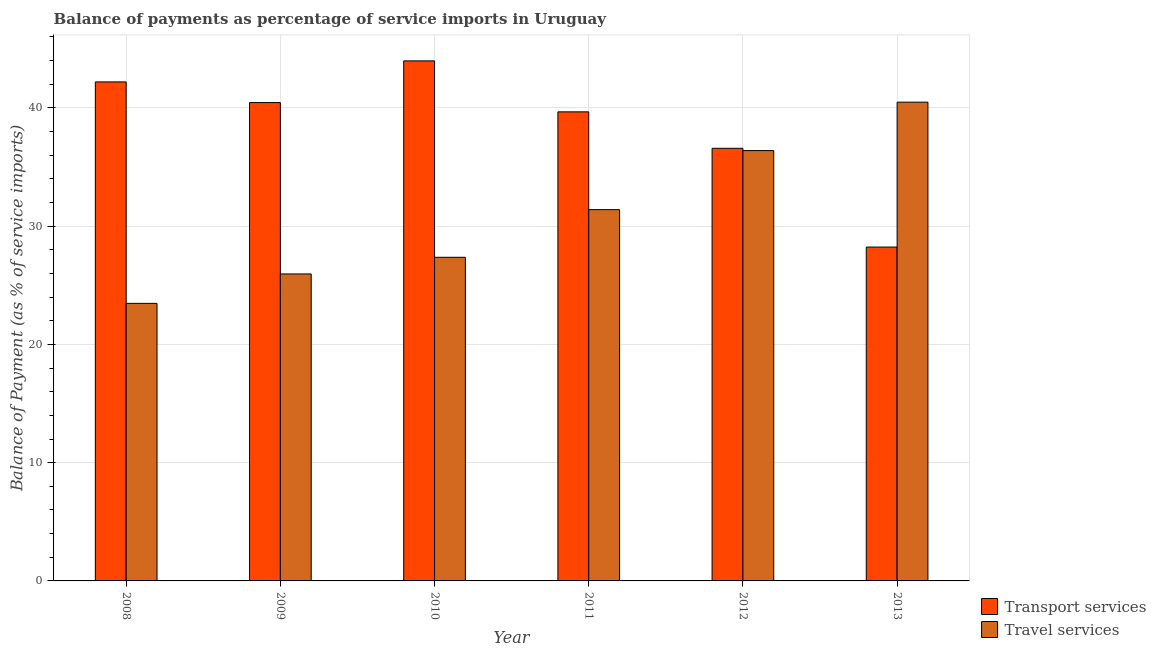How many bars are there on the 6th tick from the left?
Your answer should be compact. 2. What is the label of the 1st group of bars from the left?
Ensure brevity in your answer.  2008. In how many cases, is the number of bars for a given year not equal to the number of legend labels?
Offer a very short reply. 0. What is the balance of payments of travel services in 2008?
Offer a terse response. 23.47. Across all years, what is the maximum balance of payments of travel services?
Ensure brevity in your answer.  40.48. Across all years, what is the minimum balance of payments of transport services?
Provide a succinct answer. 28.23. In which year was the balance of payments of transport services maximum?
Offer a terse response. 2010. In which year was the balance of payments of travel services minimum?
Provide a succinct answer. 2008. What is the total balance of payments of travel services in the graph?
Your answer should be compact. 185.06. What is the difference between the balance of payments of travel services in 2008 and that in 2013?
Make the answer very short. -17.01. What is the difference between the balance of payments of travel services in 2010 and the balance of payments of transport services in 2009?
Offer a terse response. 1.41. What is the average balance of payments of travel services per year?
Provide a short and direct response. 30.84. In the year 2010, what is the difference between the balance of payments of travel services and balance of payments of transport services?
Provide a short and direct response. 0. In how many years, is the balance of payments of transport services greater than 16 %?
Your answer should be very brief. 6. What is the ratio of the balance of payments of transport services in 2008 to that in 2009?
Give a very brief answer. 1.04. What is the difference between the highest and the second highest balance of payments of transport services?
Ensure brevity in your answer.  1.78. What is the difference between the highest and the lowest balance of payments of travel services?
Your response must be concise. 17.01. Is the sum of the balance of payments of travel services in 2009 and 2012 greater than the maximum balance of payments of transport services across all years?
Offer a terse response. Yes. What does the 2nd bar from the left in 2011 represents?
Your answer should be very brief. Travel services. What does the 1st bar from the right in 2008 represents?
Provide a succinct answer. Travel services. Are all the bars in the graph horizontal?
Offer a terse response. No. How many years are there in the graph?
Your answer should be very brief. 6. What is the difference between two consecutive major ticks on the Y-axis?
Your answer should be very brief. 10. Does the graph contain grids?
Your response must be concise. Yes. Where does the legend appear in the graph?
Offer a very short reply. Bottom right. How many legend labels are there?
Make the answer very short. 2. How are the legend labels stacked?
Your answer should be very brief. Vertical. What is the title of the graph?
Your answer should be very brief. Balance of payments as percentage of service imports in Uruguay. Does "Public credit registry" appear as one of the legend labels in the graph?
Your answer should be compact. No. What is the label or title of the Y-axis?
Make the answer very short. Balance of Payment (as % of service imports). What is the Balance of Payment (as % of service imports) in Transport services in 2008?
Ensure brevity in your answer.  42.2. What is the Balance of Payment (as % of service imports) in Travel services in 2008?
Provide a succinct answer. 23.47. What is the Balance of Payment (as % of service imports) in Transport services in 2009?
Provide a succinct answer. 40.45. What is the Balance of Payment (as % of service imports) in Travel services in 2009?
Make the answer very short. 25.96. What is the Balance of Payment (as % of service imports) of Transport services in 2010?
Offer a terse response. 43.98. What is the Balance of Payment (as % of service imports) of Travel services in 2010?
Offer a terse response. 27.37. What is the Balance of Payment (as % of service imports) of Transport services in 2011?
Offer a very short reply. 39.66. What is the Balance of Payment (as % of service imports) of Travel services in 2011?
Give a very brief answer. 31.39. What is the Balance of Payment (as % of service imports) in Transport services in 2012?
Ensure brevity in your answer.  36.58. What is the Balance of Payment (as % of service imports) of Travel services in 2012?
Your answer should be very brief. 36.39. What is the Balance of Payment (as % of service imports) of Transport services in 2013?
Your answer should be very brief. 28.23. What is the Balance of Payment (as % of service imports) in Travel services in 2013?
Your answer should be compact. 40.48. Across all years, what is the maximum Balance of Payment (as % of service imports) of Transport services?
Offer a terse response. 43.98. Across all years, what is the maximum Balance of Payment (as % of service imports) in Travel services?
Your response must be concise. 40.48. Across all years, what is the minimum Balance of Payment (as % of service imports) in Transport services?
Your answer should be very brief. 28.23. Across all years, what is the minimum Balance of Payment (as % of service imports) of Travel services?
Provide a short and direct response. 23.47. What is the total Balance of Payment (as % of service imports) in Transport services in the graph?
Your response must be concise. 231.1. What is the total Balance of Payment (as % of service imports) of Travel services in the graph?
Provide a short and direct response. 185.06. What is the difference between the Balance of Payment (as % of service imports) in Transport services in 2008 and that in 2009?
Your answer should be very brief. 1.75. What is the difference between the Balance of Payment (as % of service imports) of Travel services in 2008 and that in 2009?
Make the answer very short. -2.49. What is the difference between the Balance of Payment (as % of service imports) of Transport services in 2008 and that in 2010?
Keep it short and to the point. -1.78. What is the difference between the Balance of Payment (as % of service imports) of Travel services in 2008 and that in 2010?
Your response must be concise. -3.9. What is the difference between the Balance of Payment (as % of service imports) in Transport services in 2008 and that in 2011?
Ensure brevity in your answer.  2.53. What is the difference between the Balance of Payment (as % of service imports) in Travel services in 2008 and that in 2011?
Offer a terse response. -7.92. What is the difference between the Balance of Payment (as % of service imports) in Transport services in 2008 and that in 2012?
Make the answer very short. 5.61. What is the difference between the Balance of Payment (as % of service imports) of Travel services in 2008 and that in 2012?
Your response must be concise. -12.92. What is the difference between the Balance of Payment (as % of service imports) in Transport services in 2008 and that in 2013?
Your response must be concise. 13.96. What is the difference between the Balance of Payment (as % of service imports) in Travel services in 2008 and that in 2013?
Your answer should be very brief. -17.01. What is the difference between the Balance of Payment (as % of service imports) of Transport services in 2009 and that in 2010?
Give a very brief answer. -3.53. What is the difference between the Balance of Payment (as % of service imports) of Travel services in 2009 and that in 2010?
Give a very brief answer. -1.41. What is the difference between the Balance of Payment (as % of service imports) of Transport services in 2009 and that in 2011?
Give a very brief answer. 0.78. What is the difference between the Balance of Payment (as % of service imports) in Travel services in 2009 and that in 2011?
Your answer should be very brief. -5.44. What is the difference between the Balance of Payment (as % of service imports) of Transport services in 2009 and that in 2012?
Offer a very short reply. 3.87. What is the difference between the Balance of Payment (as % of service imports) of Travel services in 2009 and that in 2012?
Offer a terse response. -10.43. What is the difference between the Balance of Payment (as % of service imports) of Transport services in 2009 and that in 2013?
Make the answer very short. 12.22. What is the difference between the Balance of Payment (as % of service imports) of Travel services in 2009 and that in 2013?
Make the answer very short. -14.52. What is the difference between the Balance of Payment (as % of service imports) of Transport services in 2010 and that in 2011?
Offer a terse response. 4.31. What is the difference between the Balance of Payment (as % of service imports) of Travel services in 2010 and that in 2011?
Offer a very short reply. -4.03. What is the difference between the Balance of Payment (as % of service imports) of Transport services in 2010 and that in 2012?
Offer a very short reply. 7.39. What is the difference between the Balance of Payment (as % of service imports) in Travel services in 2010 and that in 2012?
Provide a short and direct response. -9.02. What is the difference between the Balance of Payment (as % of service imports) in Transport services in 2010 and that in 2013?
Your answer should be compact. 15.74. What is the difference between the Balance of Payment (as % of service imports) of Travel services in 2010 and that in 2013?
Provide a short and direct response. -13.12. What is the difference between the Balance of Payment (as % of service imports) in Transport services in 2011 and that in 2012?
Offer a terse response. 3.08. What is the difference between the Balance of Payment (as % of service imports) of Travel services in 2011 and that in 2012?
Keep it short and to the point. -5. What is the difference between the Balance of Payment (as % of service imports) of Transport services in 2011 and that in 2013?
Keep it short and to the point. 11.43. What is the difference between the Balance of Payment (as % of service imports) of Travel services in 2011 and that in 2013?
Ensure brevity in your answer.  -9.09. What is the difference between the Balance of Payment (as % of service imports) of Transport services in 2012 and that in 2013?
Give a very brief answer. 8.35. What is the difference between the Balance of Payment (as % of service imports) in Travel services in 2012 and that in 2013?
Your response must be concise. -4.09. What is the difference between the Balance of Payment (as % of service imports) of Transport services in 2008 and the Balance of Payment (as % of service imports) of Travel services in 2009?
Keep it short and to the point. 16.24. What is the difference between the Balance of Payment (as % of service imports) in Transport services in 2008 and the Balance of Payment (as % of service imports) in Travel services in 2010?
Provide a short and direct response. 14.83. What is the difference between the Balance of Payment (as % of service imports) of Transport services in 2008 and the Balance of Payment (as % of service imports) of Travel services in 2011?
Provide a short and direct response. 10.8. What is the difference between the Balance of Payment (as % of service imports) in Transport services in 2008 and the Balance of Payment (as % of service imports) in Travel services in 2012?
Offer a very short reply. 5.81. What is the difference between the Balance of Payment (as % of service imports) of Transport services in 2008 and the Balance of Payment (as % of service imports) of Travel services in 2013?
Your answer should be compact. 1.71. What is the difference between the Balance of Payment (as % of service imports) in Transport services in 2009 and the Balance of Payment (as % of service imports) in Travel services in 2010?
Your answer should be very brief. 13.08. What is the difference between the Balance of Payment (as % of service imports) in Transport services in 2009 and the Balance of Payment (as % of service imports) in Travel services in 2011?
Offer a very short reply. 9.05. What is the difference between the Balance of Payment (as % of service imports) in Transport services in 2009 and the Balance of Payment (as % of service imports) in Travel services in 2012?
Your answer should be compact. 4.06. What is the difference between the Balance of Payment (as % of service imports) in Transport services in 2009 and the Balance of Payment (as % of service imports) in Travel services in 2013?
Provide a short and direct response. -0.04. What is the difference between the Balance of Payment (as % of service imports) in Transport services in 2010 and the Balance of Payment (as % of service imports) in Travel services in 2011?
Offer a terse response. 12.58. What is the difference between the Balance of Payment (as % of service imports) of Transport services in 2010 and the Balance of Payment (as % of service imports) of Travel services in 2012?
Offer a very short reply. 7.59. What is the difference between the Balance of Payment (as % of service imports) of Transport services in 2010 and the Balance of Payment (as % of service imports) of Travel services in 2013?
Make the answer very short. 3.49. What is the difference between the Balance of Payment (as % of service imports) in Transport services in 2011 and the Balance of Payment (as % of service imports) in Travel services in 2012?
Offer a very short reply. 3.27. What is the difference between the Balance of Payment (as % of service imports) of Transport services in 2011 and the Balance of Payment (as % of service imports) of Travel services in 2013?
Provide a short and direct response. -0.82. What is the difference between the Balance of Payment (as % of service imports) in Transport services in 2012 and the Balance of Payment (as % of service imports) in Travel services in 2013?
Ensure brevity in your answer.  -3.9. What is the average Balance of Payment (as % of service imports) of Transport services per year?
Offer a terse response. 38.52. What is the average Balance of Payment (as % of service imports) of Travel services per year?
Your response must be concise. 30.84. In the year 2008, what is the difference between the Balance of Payment (as % of service imports) in Transport services and Balance of Payment (as % of service imports) in Travel services?
Provide a short and direct response. 18.73. In the year 2009, what is the difference between the Balance of Payment (as % of service imports) in Transport services and Balance of Payment (as % of service imports) in Travel services?
Ensure brevity in your answer.  14.49. In the year 2010, what is the difference between the Balance of Payment (as % of service imports) in Transport services and Balance of Payment (as % of service imports) in Travel services?
Offer a terse response. 16.61. In the year 2011, what is the difference between the Balance of Payment (as % of service imports) of Transport services and Balance of Payment (as % of service imports) of Travel services?
Your answer should be very brief. 8.27. In the year 2012, what is the difference between the Balance of Payment (as % of service imports) of Transport services and Balance of Payment (as % of service imports) of Travel services?
Your answer should be very brief. 0.19. In the year 2013, what is the difference between the Balance of Payment (as % of service imports) of Transport services and Balance of Payment (as % of service imports) of Travel services?
Keep it short and to the point. -12.25. What is the ratio of the Balance of Payment (as % of service imports) in Transport services in 2008 to that in 2009?
Offer a very short reply. 1.04. What is the ratio of the Balance of Payment (as % of service imports) in Travel services in 2008 to that in 2009?
Provide a short and direct response. 0.9. What is the ratio of the Balance of Payment (as % of service imports) of Transport services in 2008 to that in 2010?
Ensure brevity in your answer.  0.96. What is the ratio of the Balance of Payment (as % of service imports) of Travel services in 2008 to that in 2010?
Your response must be concise. 0.86. What is the ratio of the Balance of Payment (as % of service imports) of Transport services in 2008 to that in 2011?
Give a very brief answer. 1.06. What is the ratio of the Balance of Payment (as % of service imports) of Travel services in 2008 to that in 2011?
Keep it short and to the point. 0.75. What is the ratio of the Balance of Payment (as % of service imports) in Transport services in 2008 to that in 2012?
Make the answer very short. 1.15. What is the ratio of the Balance of Payment (as % of service imports) in Travel services in 2008 to that in 2012?
Offer a very short reply. 0.64. What is the ratio of the Balance of Payment (as % of service imports) in Transport services in 2008 to that in 2013?
Make the answer very short. 1.49. What is the ratio of the Balance of Payment (as % of service imports) in Travel services in 2008 to that in 2013?
Give a very brief answer. 0.58. What is the ratio of the Balance of Payment (as % of service imports) in Transport services in 2009 to that in 2010?
Offer a terse response. 0.92. What is the ratio of the Balance of Payment (as % of service imports) in Travel services in 2009 to that in 2010?
Your answer should be very brief. 0.95. What is the ratio of the Balance of Payment (as % of service imports) in Transport services in 2009 to that in 2011?
Keep it short and to the point. 1.02. What is the ratio of the Balance of Payment (as % of service imports) in Travel services in 2009 to that in 2011?
Make the answer very short. 0.83. What is the ratio of the Balance of Payment (as % of service imports) in Transport services in 2009 to that in 2012?
Offer a very short reply. 1.11. What is the ratio of the Balance of Payment (as % of service imports) of Travel services in 2009 to that in 2012?
Offer a terse response. 0.71. What is the ratio of the Balance of Payment (as % of service imports) in Transport services in 2009 to that in 2013?
Offer a very short reply. 1.43. What is the ratio of the Balance of Payment (as % of service imports) of Travel services in 2009 to that in 2013?
Your answer should be very brief. 0.64. What is the ratio of the Balance of Payment (as % of service imports) in Transport services in 2010 to that in 2011?
Offer a very short reply. 1.11. What is the ratio of the Balance of Payment (as % of service imports) of Travel services in 2010 to that in 2011?
Ensure brevity in your answer.  0.87. What is the ratio of the Balance of Payment (as % of service imports) in Transport services in 2010 to that in 2012?
Offer a terse response. 1.2. What is the ratio of the Balance of Payment (as % of service imports) of Travel services in 2010 to that in 2012?
Keep it short and to the point. 0.75. What is the ratio of the Balance of Payment (as % of service imports) in Transport services in 2010 to that in 2013?
Ensure brevity in your answer.  1.56. What is the ratio of the Balance of Payment (as % of service imports) in Travel services in 2010 to that in 2013?
Your answer should be very brief. 0.68. What is the ratio of the Balance of Payment (as % of service imports) of Transport services in 2011 to that in 2012?
Your response must be concise. 1.08. What is the ratio of the Balance of Payment (as % of service imports) in Travel services in 2011 to that in 2012?
Keep it short and to the point. 0.86. What is the ratio of the Balance of Payment (as % of service imports) in Transport services in 2011 to that in 2013?
Provide a succinct answer. 1.4. What is the ratio of the Balance of Payment (as % of service imports) in Travel services in 2011 to that in 2013?
Your response must be concise. 0.78. What is the ratio of the Balance of Payment (as % of service imports) in Transport services in 2012 to that in 2013?
Your response must be concise. 1.3. What is the ratio of the Balance of Payment (as % of service imports) of Travel services in 2012 to that in 2013?
Provide a succinct answer. 0.9. What is the difference between the highest and the second highest Balance of Payment (as % of service imports) in Transport services?
Offer a very short reply. 1.78. What is the difference between the highest and the second highest Balance of Payment (as % of service imports) in Travel services?
Provide a succinct answer. 4.09. What is the difference between the highest and the lowest Balance of Payment (as % of service imports) of Transport services?
Keep it short and to the point. 15.74. What is the difference between the highest and the lowest Balance of Payment (as % of service imports) in Travel services?
Provide a succinct answer. 17.01. 